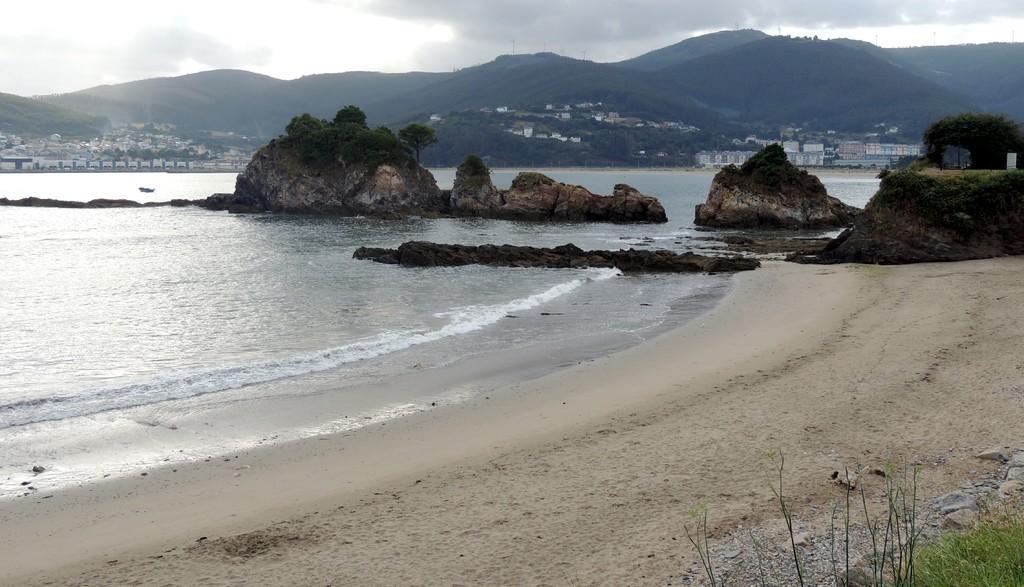Can you describe this image briefly? On the right side, there is grass on the ground near sand surface on the ground. Which is beside, tides of the ocean. In the background, there are plants on the rocks, there are buildings, there are trees, mountains and clouds in the sky. 